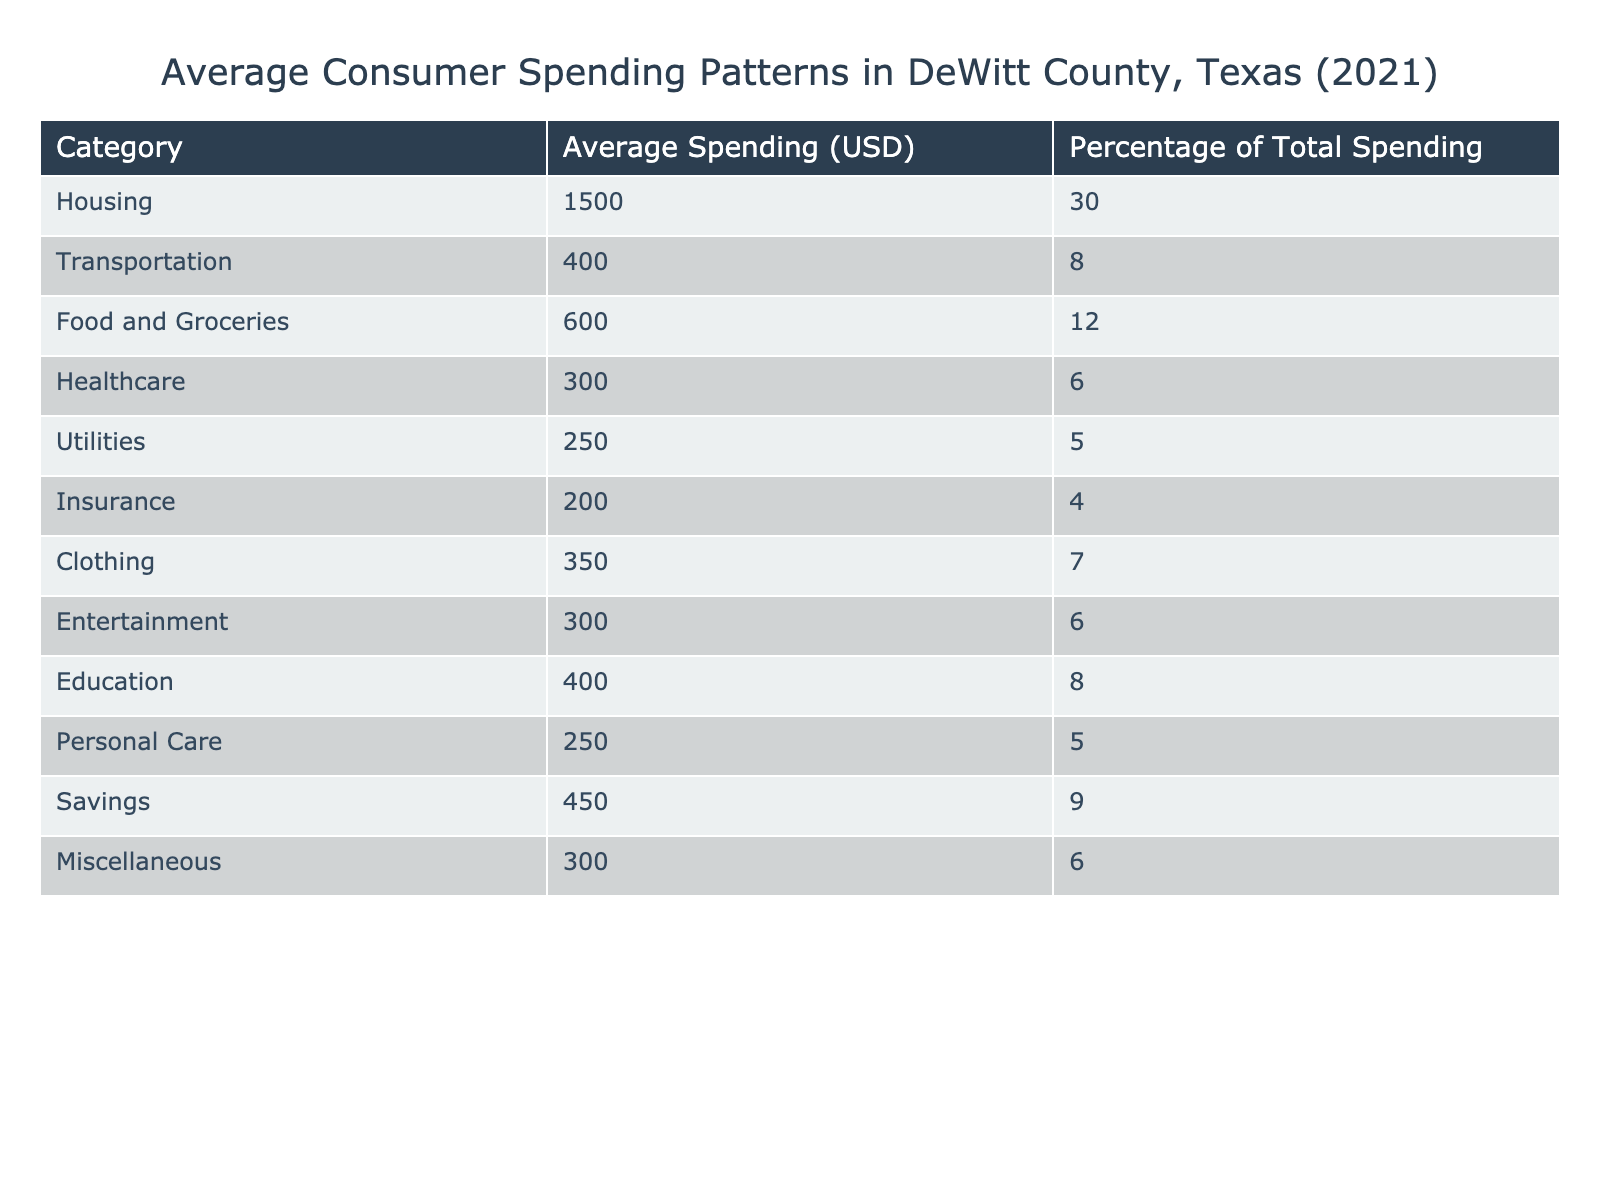What is the average spending on Housing? The table shows that the average spending on Housing in DeWitt County is listed under the "Average Spending" column for the "Housing" category, which amounts to 1500 USD.
Answer: 1500 What percentage of total spending is allocated to Food and Groceries? According to the table, the percentage of total spending for Food and Groceries is found in the "Percentage of Total Spending" column for the "Food and Groceries" category, and it is 12%.
Answer: 12% Which category has the highest average spending? By scanning the "Average Spending" column, we can see that Housing has the highest value at 1500 USD, making it the category with the highest average spending.
Answer: Housing What is the total average spending on Transportation and Healthcare combined? First, we find the average spending values for Transportation (400 USD) and Healthcare (300 USD) from the table. Then, we sum these values: 400 + 300 = 700 USD.
Answer: 700 Is the average spending on Entertainment greater than 250 USD? Looking at the table, the average spending on Entertainment is 300 USD, which is greater than 250 USD, confirming the statement is true.
Answer: Yes What is the average spending on Utilities and Personal Care? The average spending on Utilities is 250 USD and Personal Care is also 250 USD. To find the average, we sum them up: 250 + 250 = 500 USD, then divide by 2, resulting in 250 USD.
Answer: 250 How much more is spent on Clothing compared to Insurance? Average spending on Clothing is 350 USD, and for Insurance, it is 200 USD. The difference is 350 - 200 = 150 USD, indicating that Clothing spending exceeds Insurance spending by 150 USD.
Answer: 150 What is the percentage of total spending on Savings relative to the total average spending? The table lists the percentage of total spending on Savings as 9%. To evaluate if this is a significant portion, we can compare it to categories like Housing (30%), but for this question, the answer is simply that Savings accounts for 9%.
Answer: 9 Which two categories have the lowest average spending? From the "Average Spending" column, we identify the lowest values, which are Insurance (200 USD) and Healthcare (300 USD). These are the two categories with the lowest average spending.
Answer: Insurance and Healthcare 